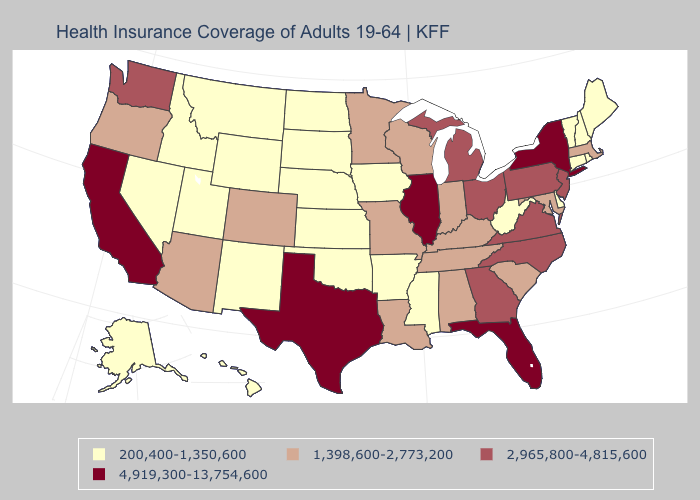Which states have the highest value in the USA?
Write a very short answer. California, Florida, Illinois, New York, Texas. Among the states that border Arkansas , which have the lowest value?
Answer briefly. Mississippi, Oklahoma. How many symbols are there in the legend?
Answer briefly. 4. Does Mississippi have the lowest value in the USA?
Quick response, please. Yes. Does the map have missing data?
Write a very short answer. No. Does South Carolina have a lower value than Florida?
Short answer required. Yes. What is the highest value in states that border West Virginia?
Concise answer only. 2,965,800-4,815,600. Name the states that have a value in the range 4,919,300-13,754,600?
Write a very short answer. California, Florida, Illinois, New York, Texas. What is the value of Massachusetts?
Quick response, please. 1,398,600-2,773,200. What is the highest value in the USA?
Write a very short answer. 4,919,300-13,754,600. Name the states that have a value in the range 2,965,800-4,815,600?
Quick response, please. Georgia, Michigan, New Jersey, North Carolina, Ohio, Pennsylvania, Virginia, Washington. Name the states that have a value in the range 1,398,600-2,773,200?
Be succinct. Alabama, Arizona, Colorado, Indiana, Kentucky, Louisiana, Maryland, Massachusetts, Minnesota, Missouri, Oregon, South Carolina, Tennessee, Wisconsin. Which states have the lowest value in the MidWest?
Answer briefly. Iowa, Kansas, Nebraska, North Dakota, South Dakota. What is the lowest value in states that border North Carolina?
Concise answer only. 1,398,600-2,773,200. Name the states that have a value in the range 2,965,800-4,815,600?
Concise answer only. Georgia, Michigan, New Jersey, North Carolina, Ohio, Pennsylvania, Virginia, Washington. 